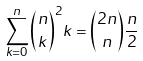Convert formula to latex. <formula><loc_0><loc_0><loc_500><loc_500>\sum _ { k = 0 } ^ { n } \binom { n } { k } ^ { 2 } k = \binom { 2 n } { n } \frac { n } { 2 }</formula> 